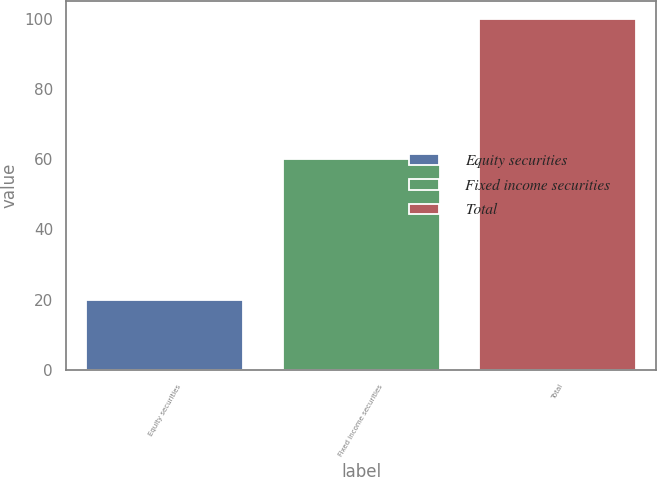<chart> <loc_0><loc_0><loc_500><loc_500><bar_chart><fcel>Equity securities<fcel>Fixed income securities<fcel>Total<nl><fcel>20<fcel>60<fcel>100<nl></chart> 